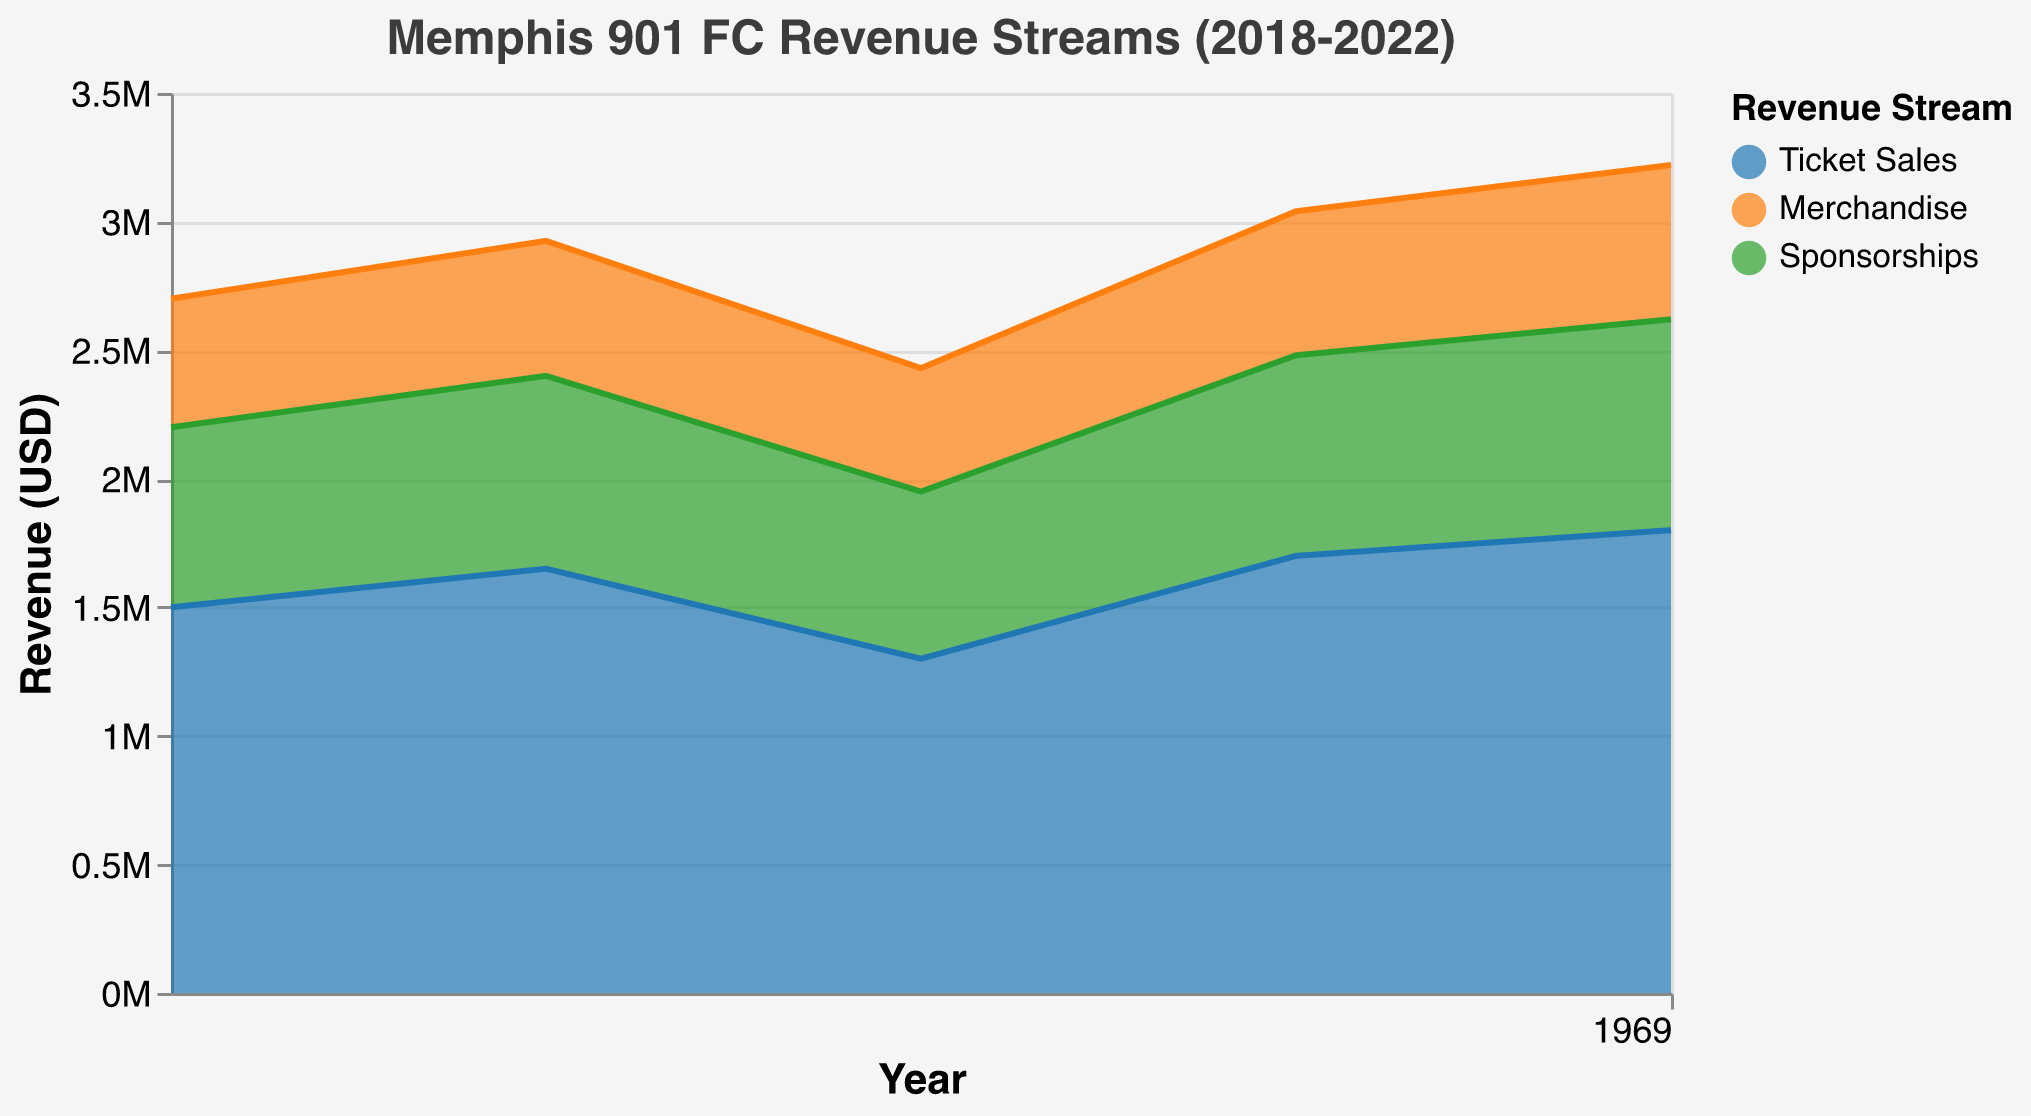What is the total revenue for Memphis 901 FC in 2021? Based on the chart, we need to sum the revenues from Ticket Sales, Merchandise, and Sponsorships for 2021. Total revenue = Ticket Sales (1,700,000 USD) + Merchandise (560,000 USD) + Sponsorships (780,000 USD) = 3,040,000 USD.
Answer: 3,040,000 USD How did Ticket Sales revenue trend from 2018 to 2022? Observing the area chart, we see that Ticket Sales started at 1,500,000 USD in 2018, showed an upward trend, dropped in 2020, and then increased again in 2021 and 2022, reaching 1,800,000 USD.
Answer: Increasing with a dip in 2020 What is the lowest revenue from merchandise over the years? We need to identify the smallest value in the Merchandise category. Merchandise revenue was 500,000 USD in 2018, 525,000 USD in 2019, 480,000 USD in 2020, 560,000 USD in 2021, and 600,000 USD in 2022. The lowest figure is 480,000 USD from 2020.
Answer: 480,000 USD How did Sponsorships revenue change from 2019 to 2020? Observing the Sponsorship revenue for 2019 (750,000 USD) and 2020 (650,000 USD), it decreased by 100,000 USD.
Answer: Decreased by 100,000 USD Which revenue stream had the highest increase from 2021 to 2022? We need to compare the revenue streams from 2021 to 2022. Ticket Sales increased from 1,700,000 USD to 1,800,000 USD (100,000 USD), Merchandise increased from 560,000 USD to 600,000 USD (40,000 USD), and Sponsorships increased from 780,000 USD to 820,000 USD (40,000 USD). Thus, Ticket Sales had the highest increase.
Answer: Ticket Sales What was the percentage increase in total revenue from 2020 to 2021? First, calculate the total revenue for 2020: 1,300,000 USD (Ticket Sales) + 480,000 USD (Merchandise) + 650,000 USD (Sponsorships) = 2,430,000 USD, and for 2021: 1,700,000 USD (Ticket Sales) + 560,000 USD (Merchandise) + 780,000 USD (Sponsorships) = 3,040,000 USD. The percentage increase = [(3,040,000 - 2,430,000) / 2,430,000] * 100 ≈ 25.10%.
Answer: Approximately 25.10% Which year had the highest combined revenue, and what was the amount? We need to calculate the total combined revenue for each year. From the chart, 2022 has the highest total combined revenue: 1,800,000 USD (Ticket Sales) + 600,000 USD (Merchandise) + 820,000 USD (Sponsorships) = 3,220,000 USD.
Answer: 2022 with 3,220,000 USD What is the trend in Merchandise revenue over the given years? Observing the area chart, we see that Merchandise revenue showed an upward trend over the years, starting at 500,000 USD in 2018 and reaching 600,000 USD in 2022, with a minor drop in 2020.
Answer: Increasing with a minor drop Compare the Ticket Sales revenue in 2018 with that in 2022. From the chart, Ticket Sales were 1,500,000 USD in 2018 and increased to 1,800,000 USD in 2022. Hence, there's an increase of 300,000 USD.
Answer: Increased by 300,000 USD 